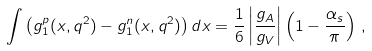<formula> <loc_0><loc_0><loc_500><loc_500>\int \left ( { { g _ { 1 } ^ { p } } ( x , q ^ { 2 } ) - g _ { 1 } ^ { n } ( x , q ^ { 2 } ) } \right ) d x = \frac { 1 } { 6 } \left | { \frac { g _ { A } } { g _ { V } } } \right | \left ( { 1 - \frac { \alpha _ { s } } { \pi } } \right ) \, ,</formula> 